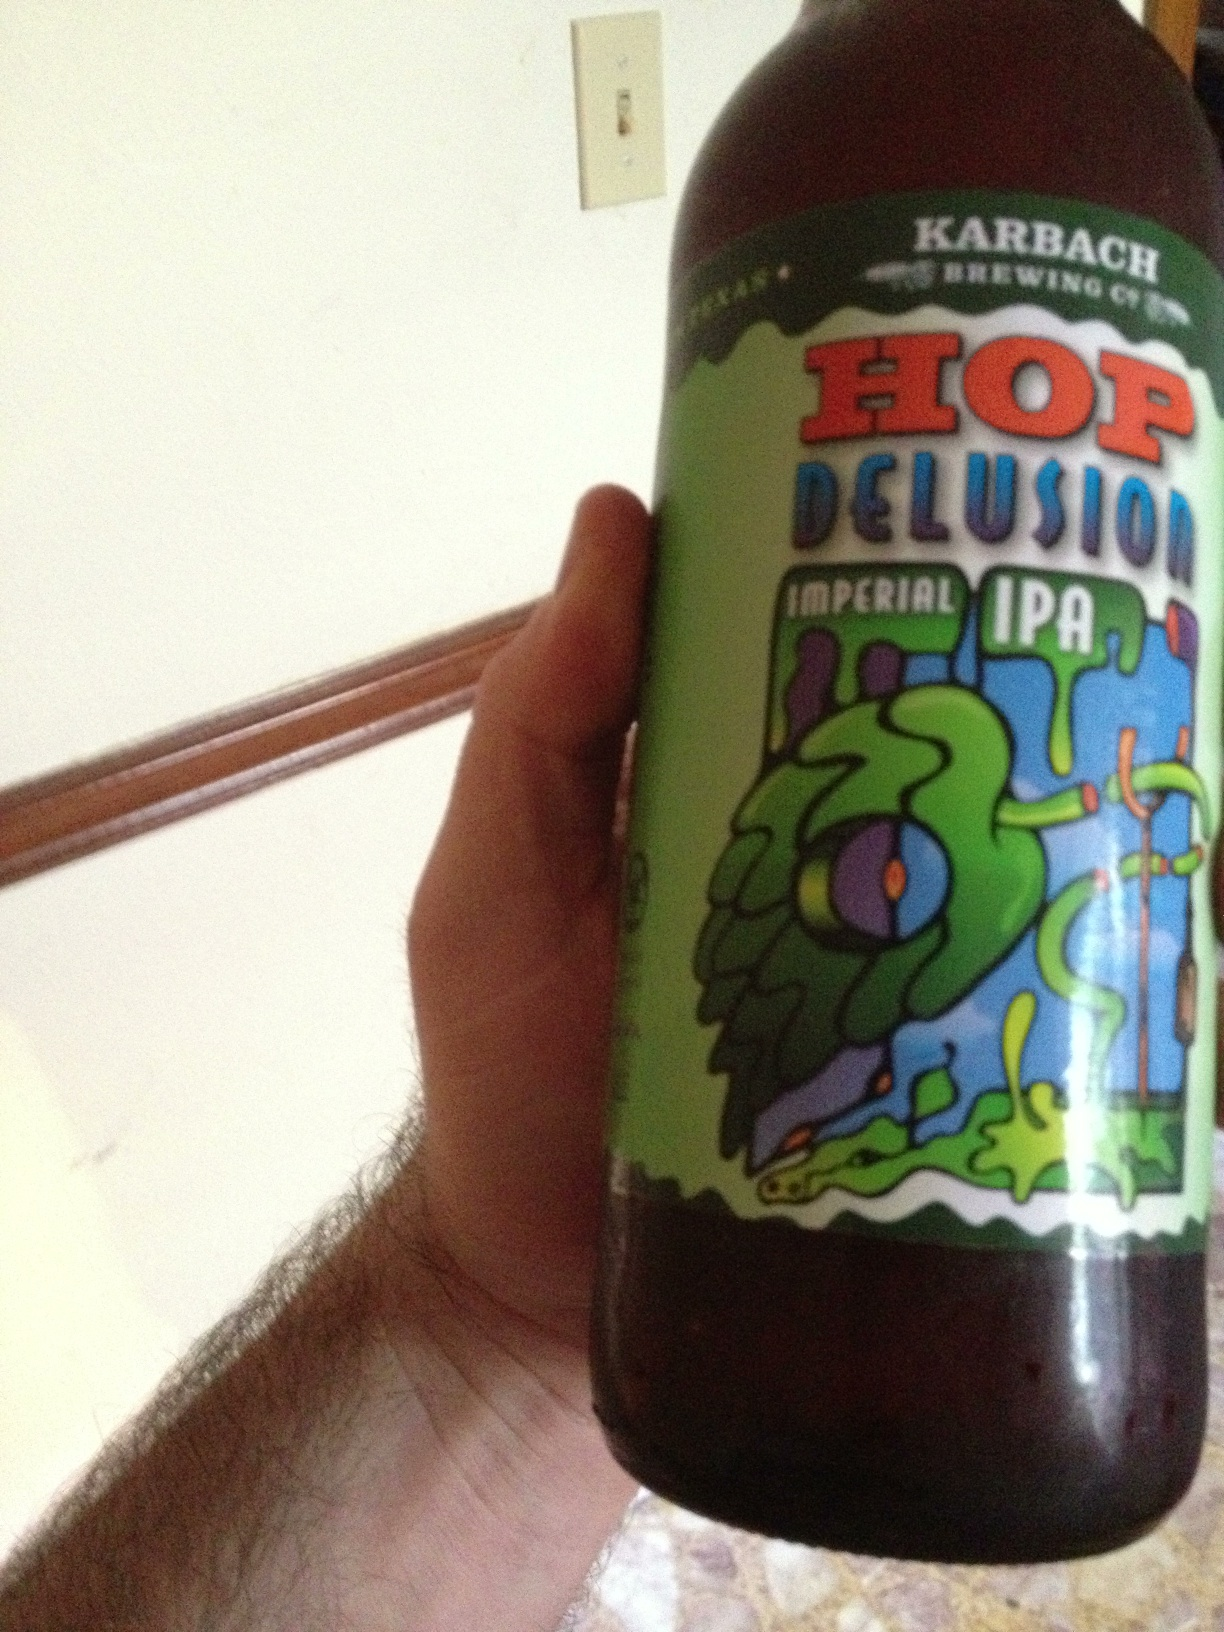Imagine if this beer had a character. What would it be like? If Hop Delusion Imperial IPA were a character, it would be a daring adventurer, always seeking out new and thrilling experiences. With a bold and vibrant personality, it would thrive on excitement and have an infectious zest for life, much like the dynamic flavors of the beer itself. 